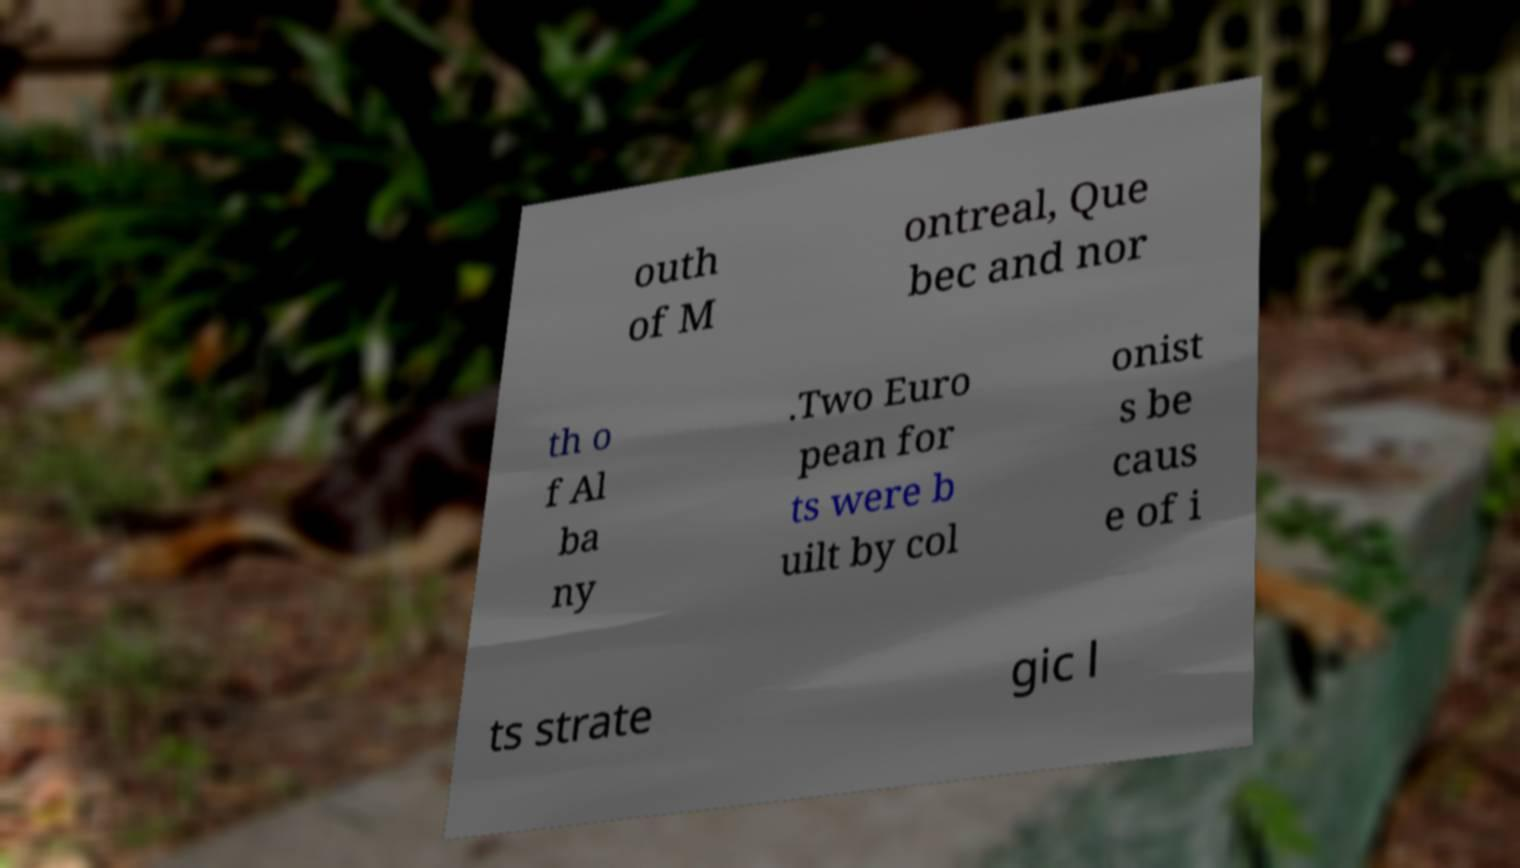Please read and relay the text visible in this image. What does it say? outh of M ontreal, Que bec and nor th o f Al ba ny .Two Euro pean for ts were b uilt by col onist s be caus e of i ts strate gic l 